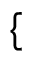<formula> <loc_0><loc_0><loc_500><loc_500>\{</formula> 